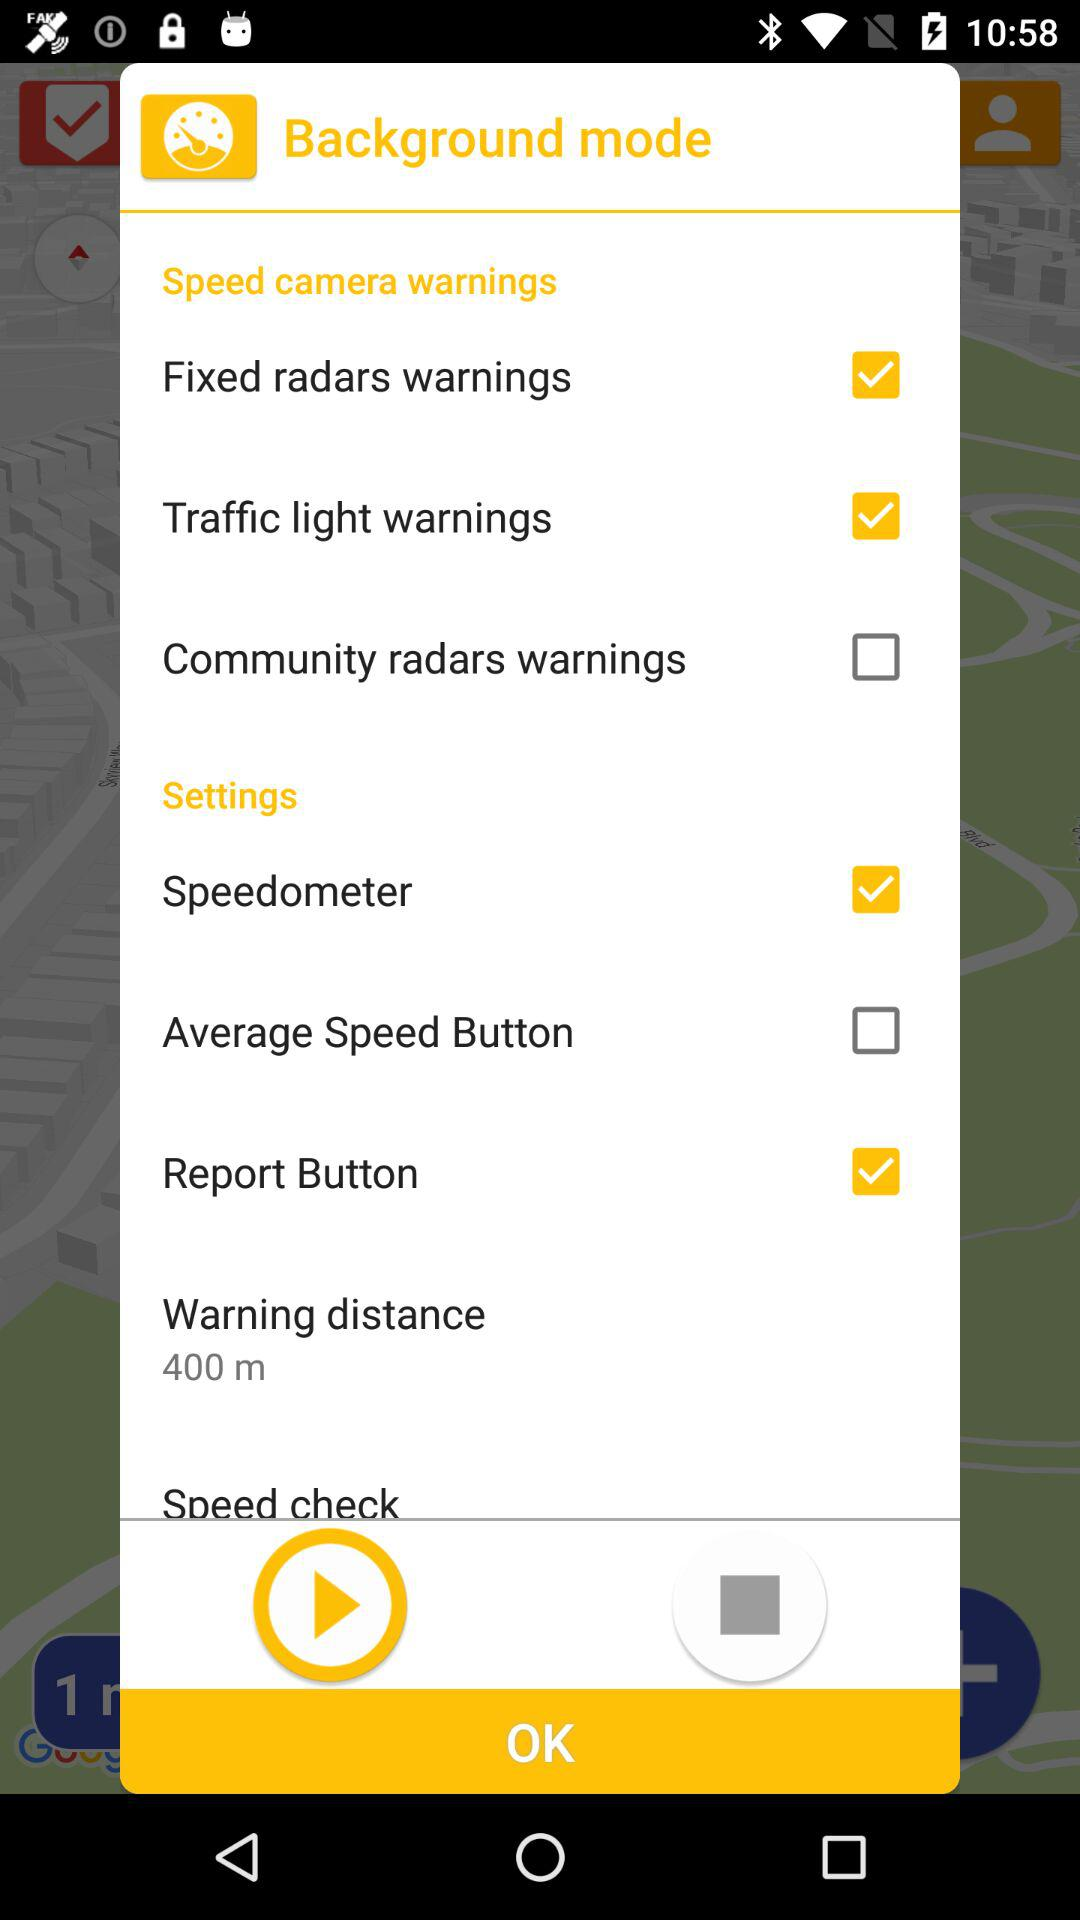I see an option for 'Warning distance'. Can I change it, and if so, how? The 'Warning distance' option currently displays '400 m,' which suggests that the application warns the driver of upcoming speed cameras or traffic lights at that distance. It's likely this value can be changed to suit the driver's preference by tapping on the setting, which would then allow you to select a different warning distance from predetermined options or enter a custom value. 